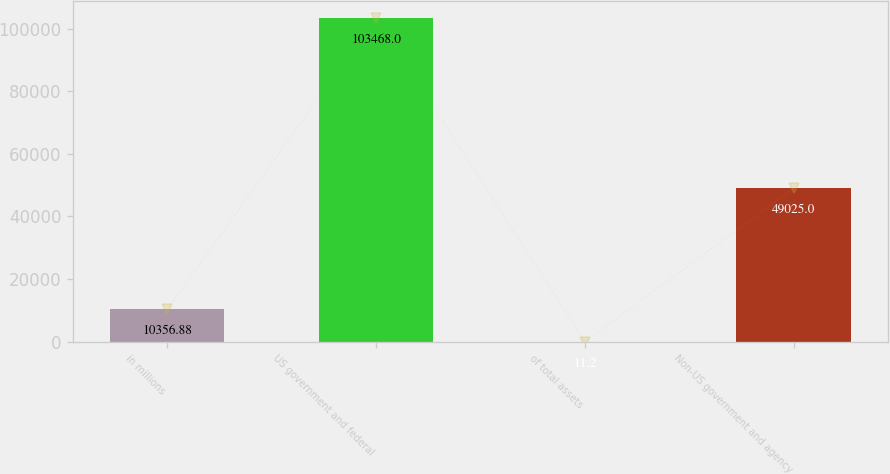Convert chart to OTSL. <chart><loc_0><loc_0><loc_500><loc_500><bar_chart><fcel>in millions<fcel>US government and federal<fcel>of total assets<fcel>Non-US government and agency<nl><fcel>10356.9<fcel>103468<fcel>11.2<fcel>49025<nl></chart> 